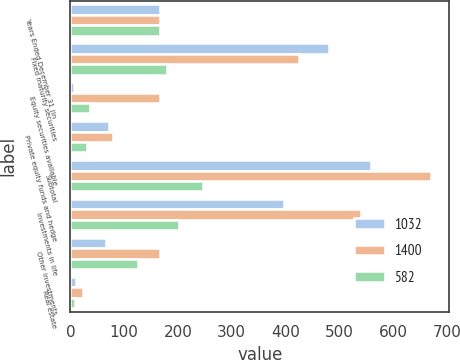<chart> <loc_0><loc_0><loc_500><loc_500><stacked_bar_chart><ecel><fcel>Years Ended December 31 (in<fcel>Fixed maturity securities<fcel>Equity securities available<fcel>Private equity funds and hedge<fcel>Subtotal<fcel>Investments in life<fcel>Other investments<fcel>Real estate<nl><fcel>1032<fcel>166<fcel>480<fcel>7<fcel>72<fcel>559<fcel>397<fcel>66<fcel>10<nl><fcel>1400<fcel>166<fcel>425<fcel>166<fcel>80<fcel>671<fcel>540<fcel>166<fcel>23<nl><fcel>582<fcel>166<fcel>180<fcel>37<fcel>30<fcel>247<fcel>201<fcel>126<fcel>8<nl></chart> 